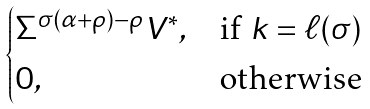<formula> <loc_0><loc_0><loc_500><loc_500>\begin{cases} \Sigma ^ { \sigma ( \alpha + \rho ) - \rho } V ^ { * } , & \text {if $k = \ell(\sigma)$} \\ 0 , & \text {otherwise} \end{cases}</formula> 